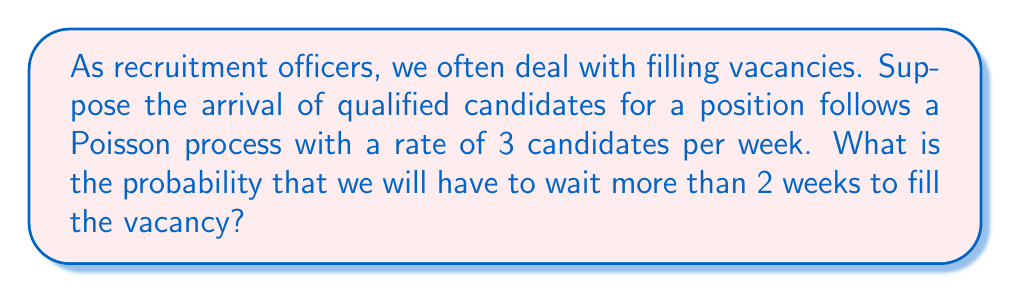Give your solution to this math problem. Let's approach this step-by-step:

1) In a Poisson process, the time until the first event (in this case, the arrival of a qualified candidate) follows an exponential distribution.

2) If $X$ is the time until the first arrival, then $X \sim \text{Exp}(\lambda)$, where $\lambda$ is the rate parameter.

3) In this case, $\lambda = 3$ candidates per week.

4) We want to find $P(X > 2)$, the probability that the time until the first arrival is more than 2 weeks.

5) For an exponential distribution:

   $P(X > t) = e^{-\lambda t}$

6) Substituting our values:

   $P(X > 2) = e^{-3 \cdot 2} = e^{-6}$

7) We can calculate this value:

   $e^{-6} \approx 0.00248$

Therefore, the probability of waiting more than 2 weeks to fill the vacancy is approximately 0.00248 or about 0.248%.
Answer: $e^{-6} \approx 0.00248$ 